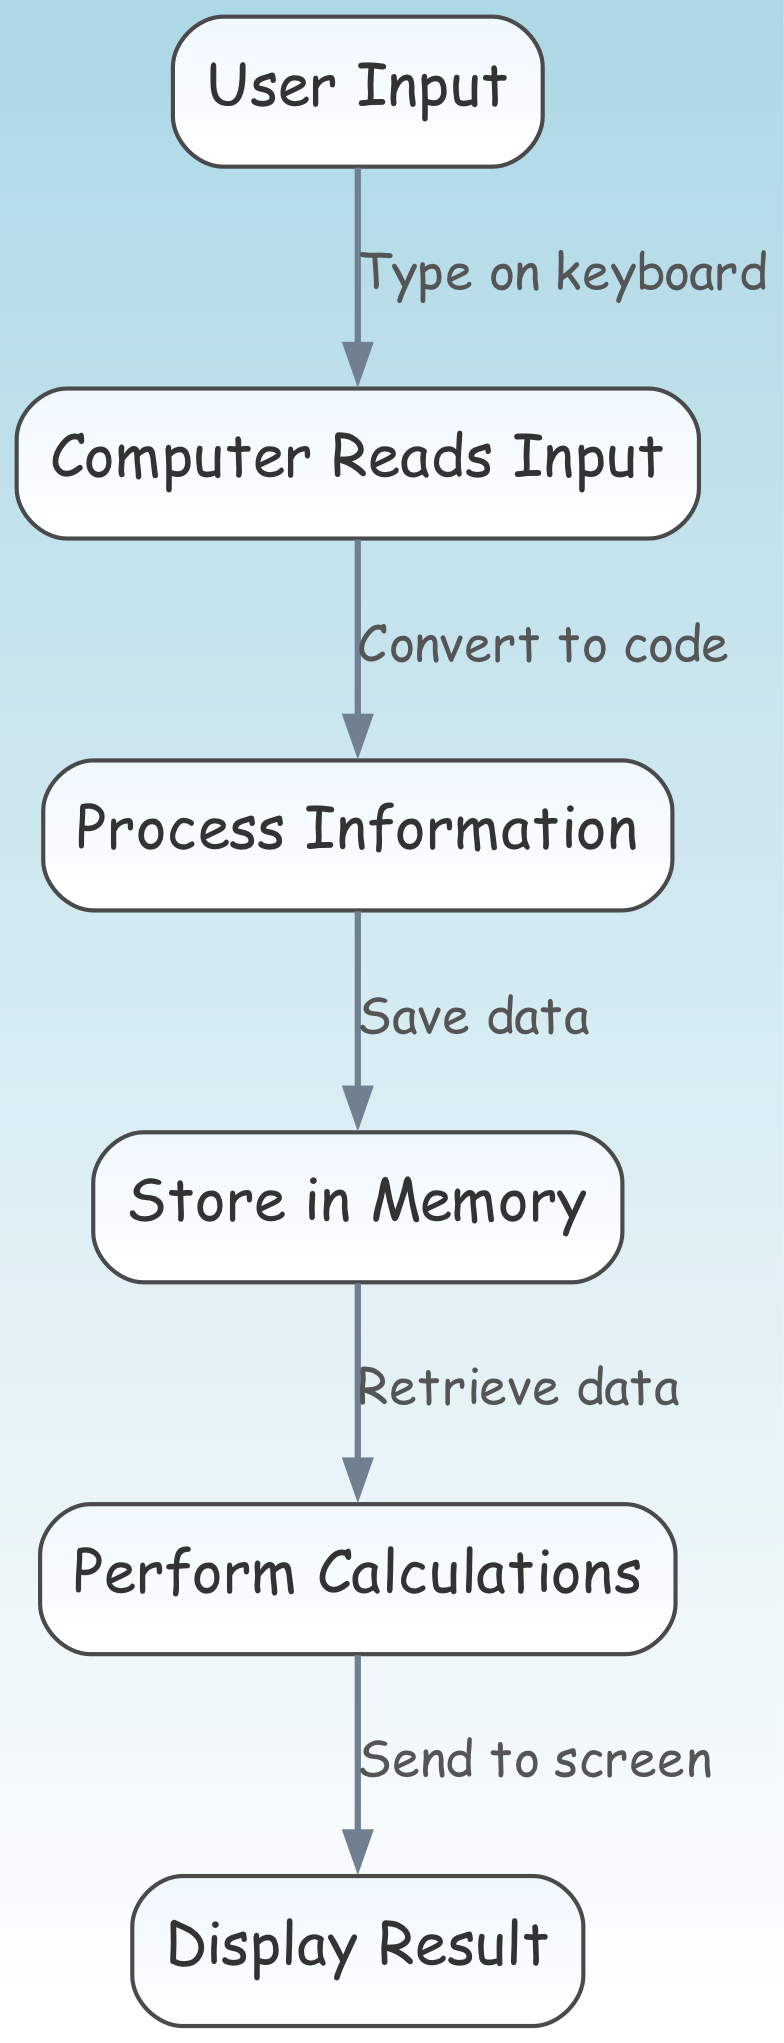What is the first step in executing a computer program? The first step shown in the diagram is "User Input." This node represents the action of the user typing something, which initiates the program execution process. From the diagram, the flow starts at this node.
Answer: User Input How many nodes are present in the diagram? By counting the nodes listed in the data, we see there are 6 unique nodes: User Input, Computer Reads Input, Process Information, Store in Memory, Perform Calculations, and Display Result. Therefore, the total is 6 nodes.
Answer: 6 What does the computer do after reading input? According to the directed graph, after the node "Computer Reads Input," the next step is "Process Information." This indicates that the computer takes the input and processes it as the next logical step.
Answer: Process Information What action does the computer take after storing data in memory? After the node "Store in Memory," the next action as per the flow is "Perform Calculations." This means that once the data is saved in memory, the computer proceeds to perform any necessary calculations with that data.
Answer: Perform Calculations What is the relationship between User Input and Computer Reads Input? The directed edge between "User Input" and "Computer Reads Input" is labeled "Type on keyboard." This indicates that the action taken at the User Input node (typing) is what leads to the computer reading that input.
Answer: Type on keyboard What is displayed as a result of the program execution? The last step in the flow is "Display Result." This node indicates that the outcome of the program, following all preceding processing steps, is shown to the user. Therefore, the result ultimately displayed is from this node.
Answer: Display Result How does data move from memory to the calculation step? The edge connecting "Store in Memory" to "Perform Calculations" is labeled "Retrieve data." This illustrates the specific action of retrieving the data previously stored in memory to use for calculations in the next step overall.
Answer: Retrieve data Which process comes directly before output? Directly preceding the "Display Result" node, according to the diagram, is "Perform Calculations." This shows that the calculations need to be completed before the results can be displayed to the user.
Answer: Perform Calculations 